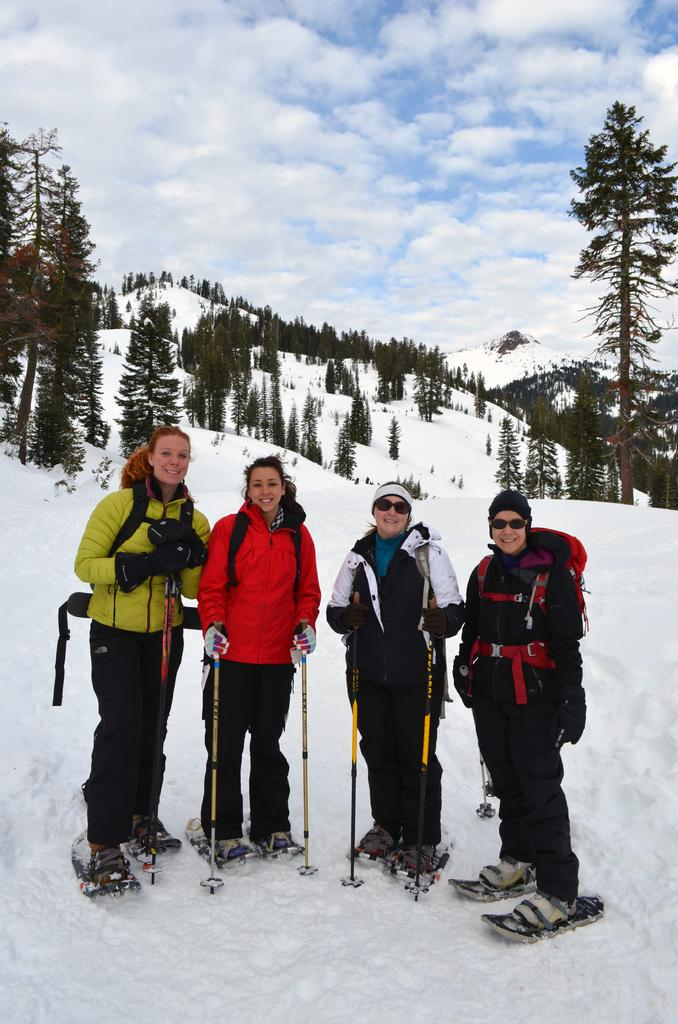How many people are in the image? There are 4 people in the image. What is the surface on which the people are standing? The people are standing on the snow. What are the people holding in their hands? The people are holding sticks in their hands. What can be seen in the background of the image? There are trees visible in the background. How would you describe the sky in the image? The sky is cloudy in the image. What type of lumber is being used by the people in the image? There is no lumber present in the image; the people are holding sticks. How does the nerve system of the trees in the background affect the image? The image does not show or discuss the nerve system of the trees; it only shows their presence in the background. 